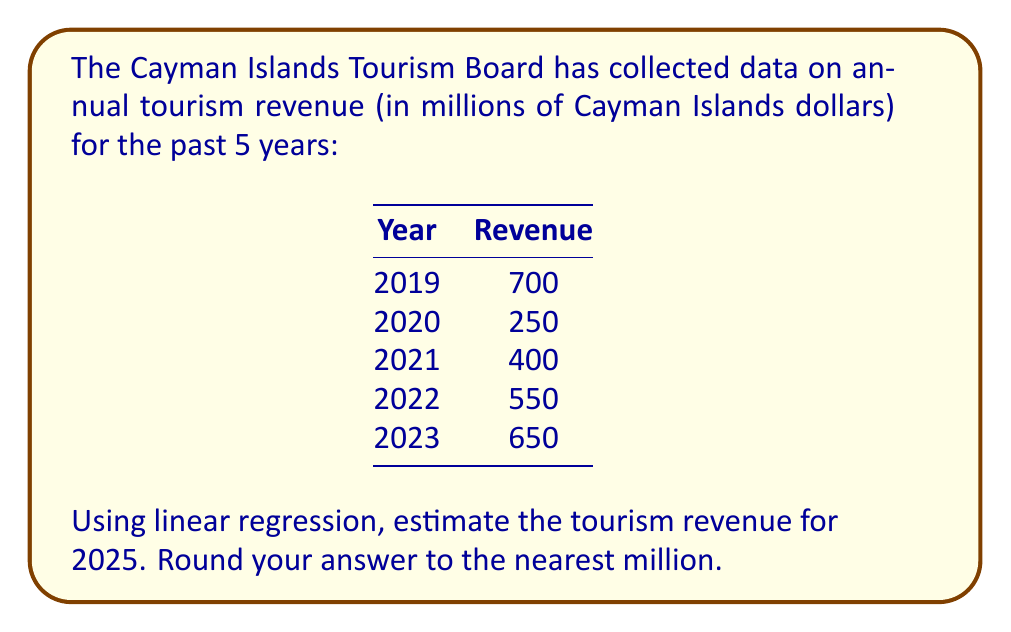Provide a solution to this math problem. To estimate the tourism revenue for 2025 using linear regression, we'll follow these steps:

1) Let x represent the year (with 2019 as x = 0) and y represent the revenue.

2) Calculate the means of x and y:
   $\bar{x} = (0 + 1 + 2 + 3 + 4) / 5 = 2$
   $\bar{y} = (700 + 250 + 400 + 550 + 650) / 5 = 510$

3) Calculate $\sum(x - \bar{x})(y - \bar{y})$ and $\sum(x - \bar{x})^2$:

   $\sum(x - \bar{x})(y - \bar{y}) = (0-2)(700-510) + (1-2)(250-510) + (2-2)(400-510) + (3-2)(550-510) + (4-2)(650-510)$
                                   $= -380 - 260 + 0 + 40 + 280 = -320$

   $\sum(x - \bar{x})^2 = (0-2)^2 + (1-2)^2 + (2-2)^2 + (3-2)^2 + (4-2)^2 = 4 + 1 + 0 + 1 + 4 = 10$

4) Calculate the slope (m) of the regression line:
   $m = \frac{\sum(x - \bar{x})(y - \bar{y})}{\sum(x - \bar{x})^2} = \frac{-320}{10} = -32$

5) Calculate the y-intercept (b) using $y = mx + b$:
   $510 = -32(2) + b$
   $b = 510 + 64 = 574$

6) The regression line equation is:
   $y = -32x + 574$

7) For 2025, x = 6 (as 2019 is x = 0). Substitute this into the equation:
   $y = -32(6) + 574 = -192 + 574 = 382$

Therefore, the estimated tourism revenue for 2025 is 382 million Cayman Islands dollars.
Answer: $382 million 